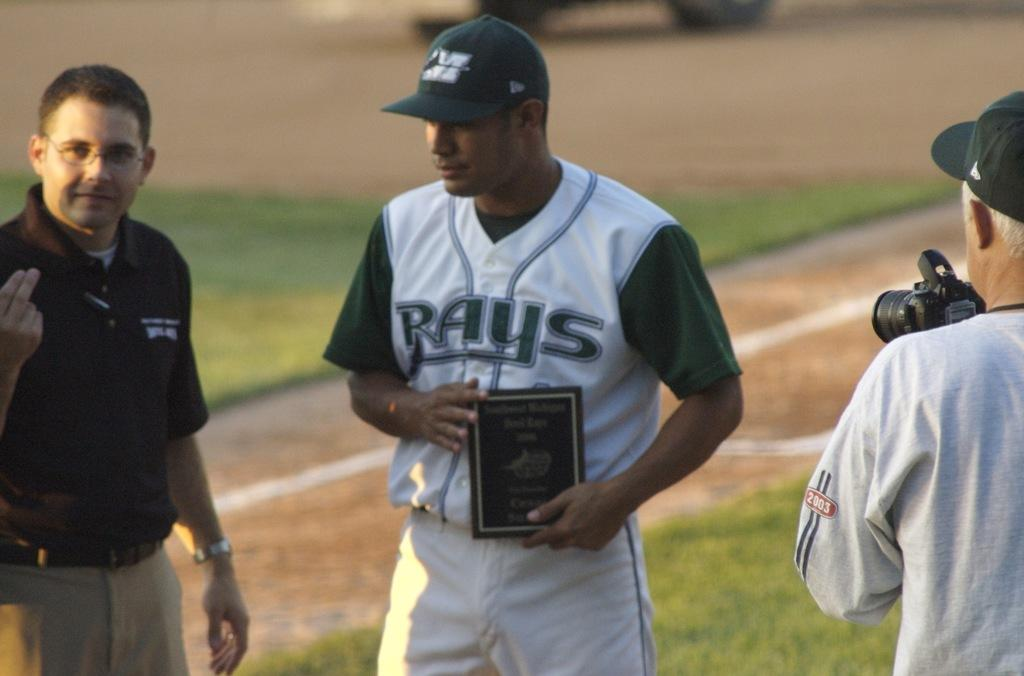<image>
Offer a succinct explanation of the picture presented. A Rays baseball player holds an award while standing on the field. 